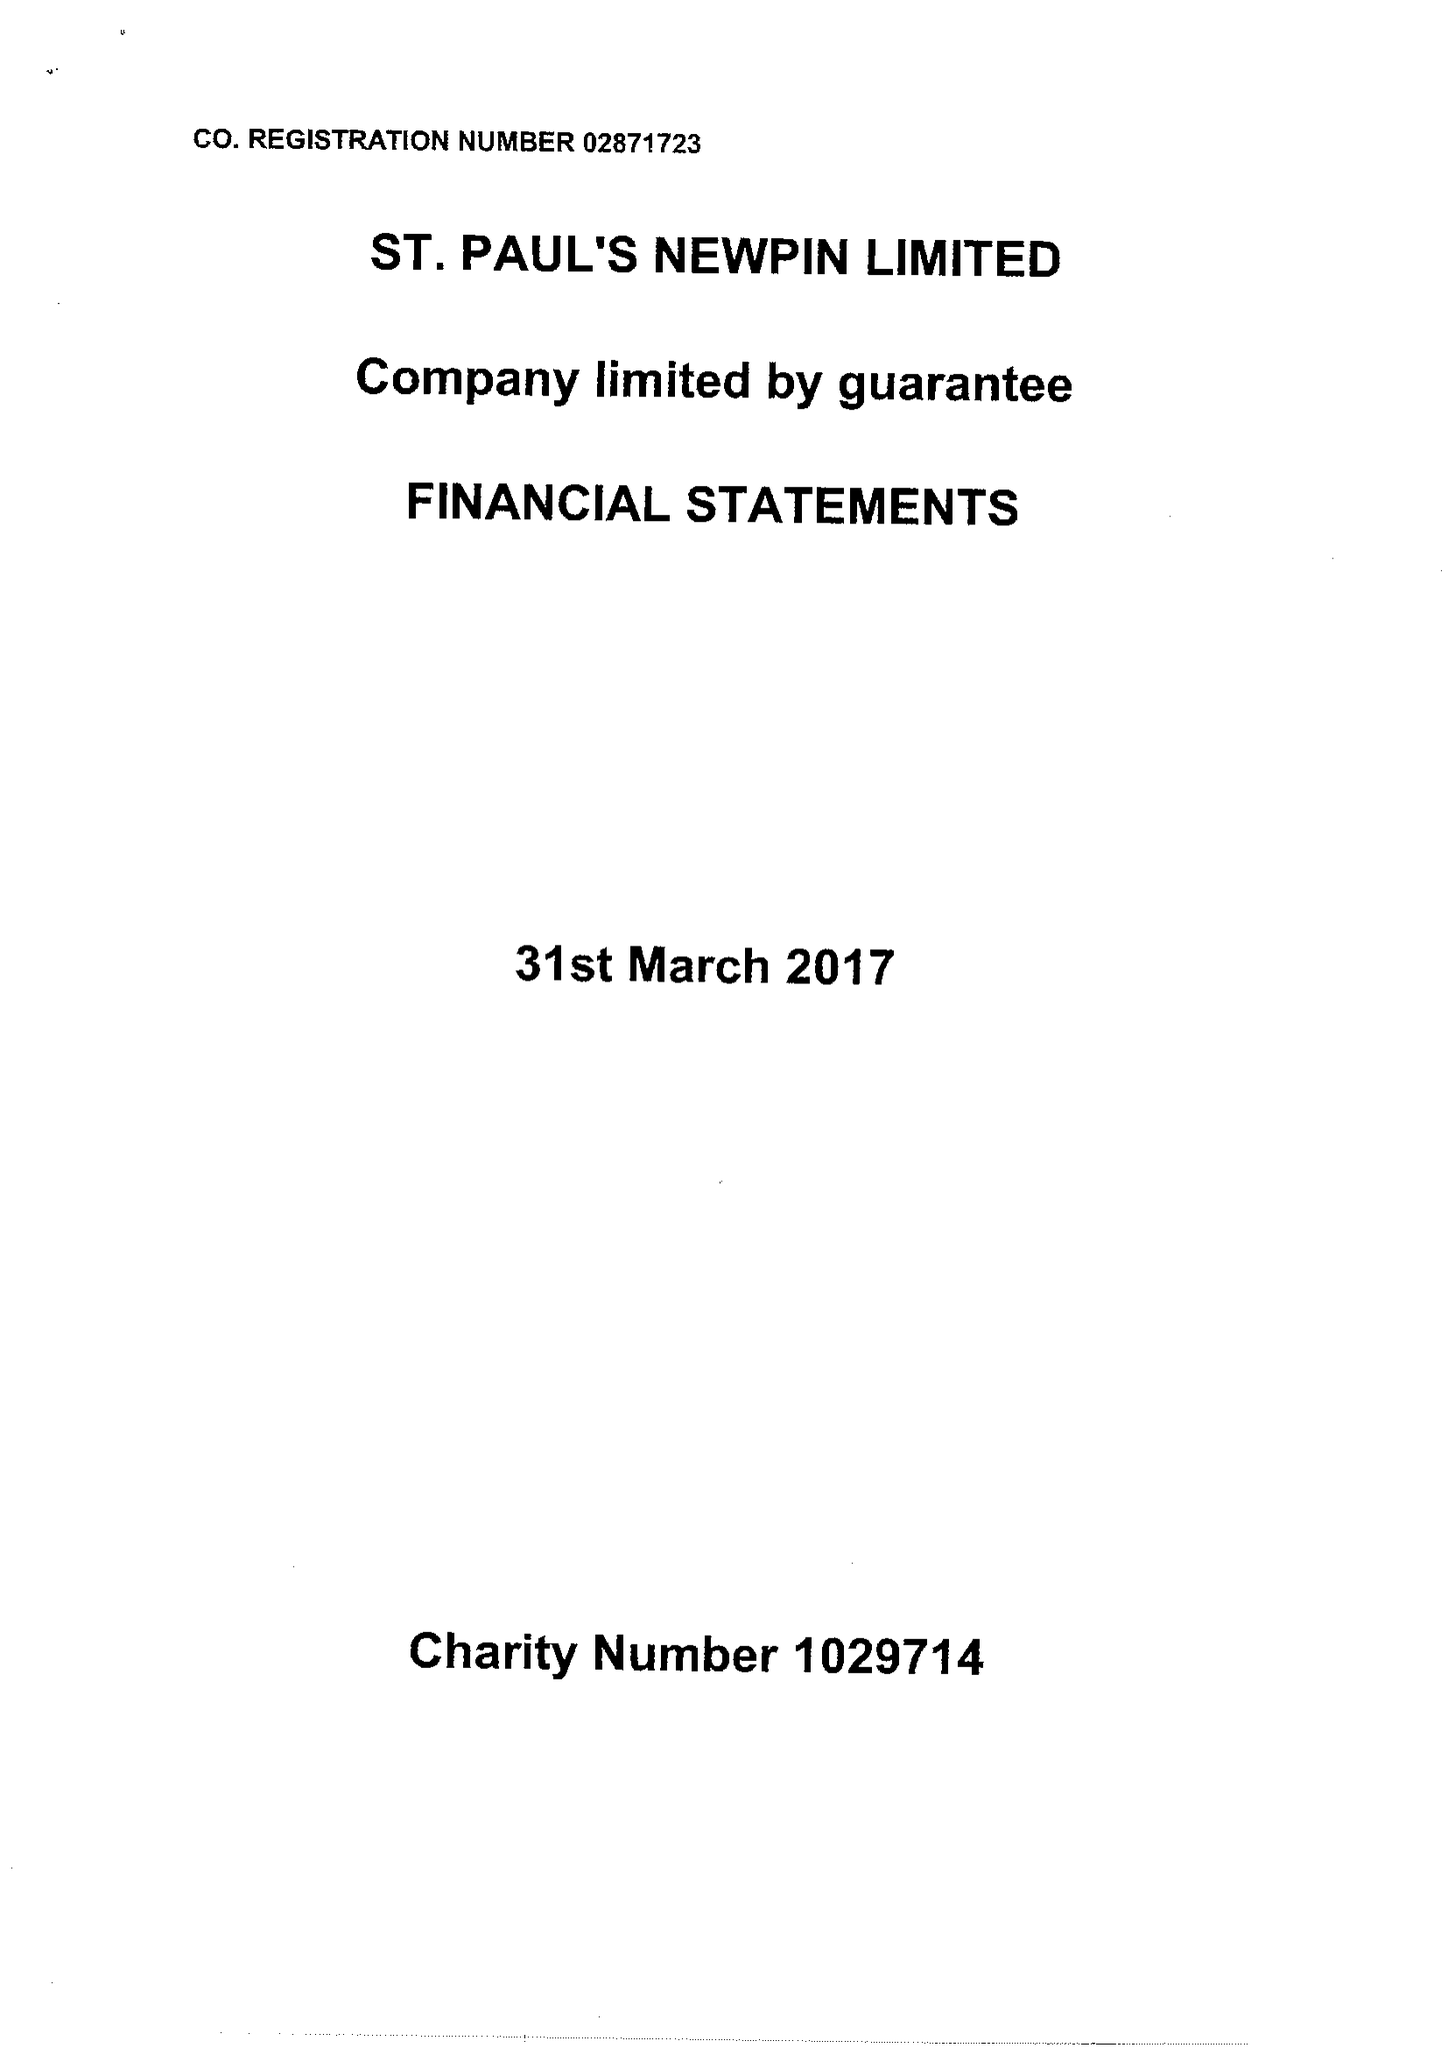What is the value for the income_annually_in_british_pounds?
Answer the question using a single word or phrase. 104953.00 